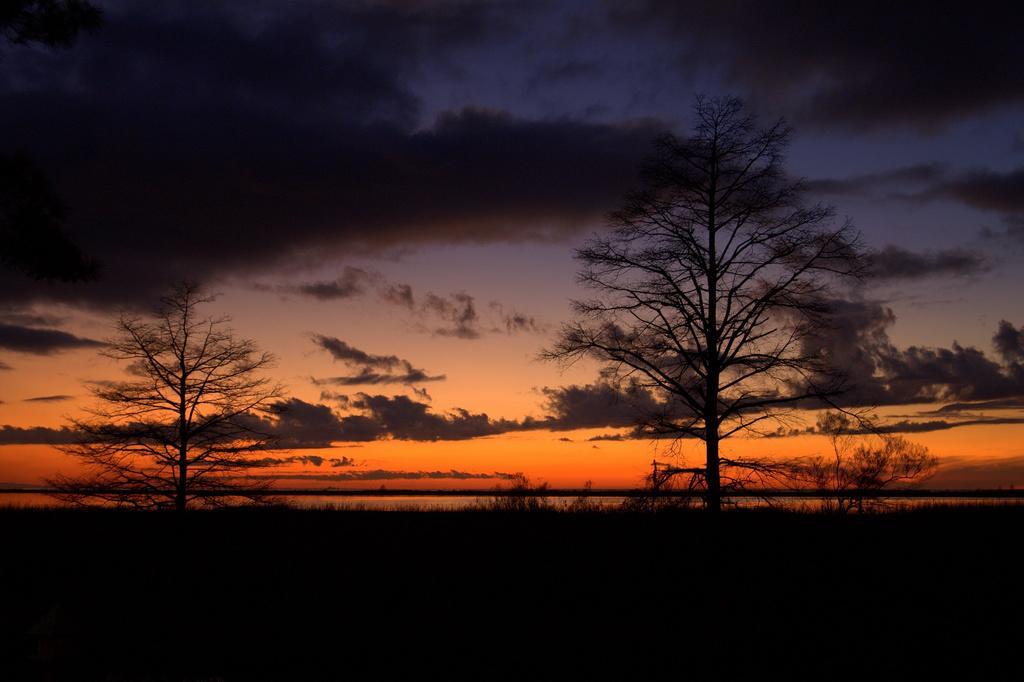Can you describe this image briefly? In this image, we can see some trees. We can see some water and the sky with clouds. 